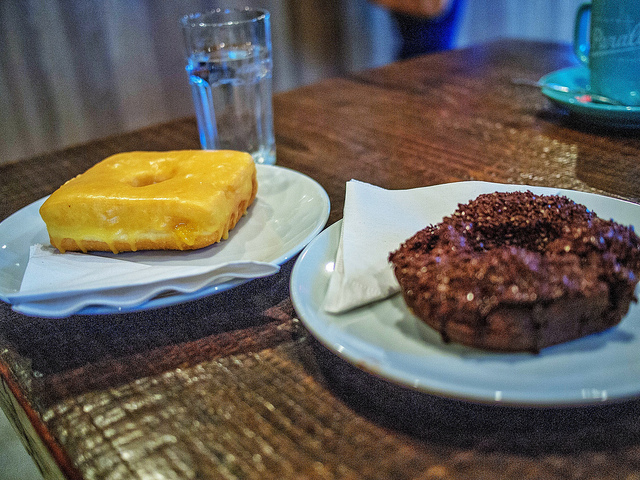How many donuts are there? 2 